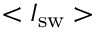Convert formula to latex. <formula><loc_0><loc_0><loc_500><loc_500>< I _ { s w } ></formula> 